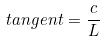Convert formula to latex. <formula><loc_0><loc_0><loc_500><loc_500>t a n g e n t = \frac { c } { L }</formula> 